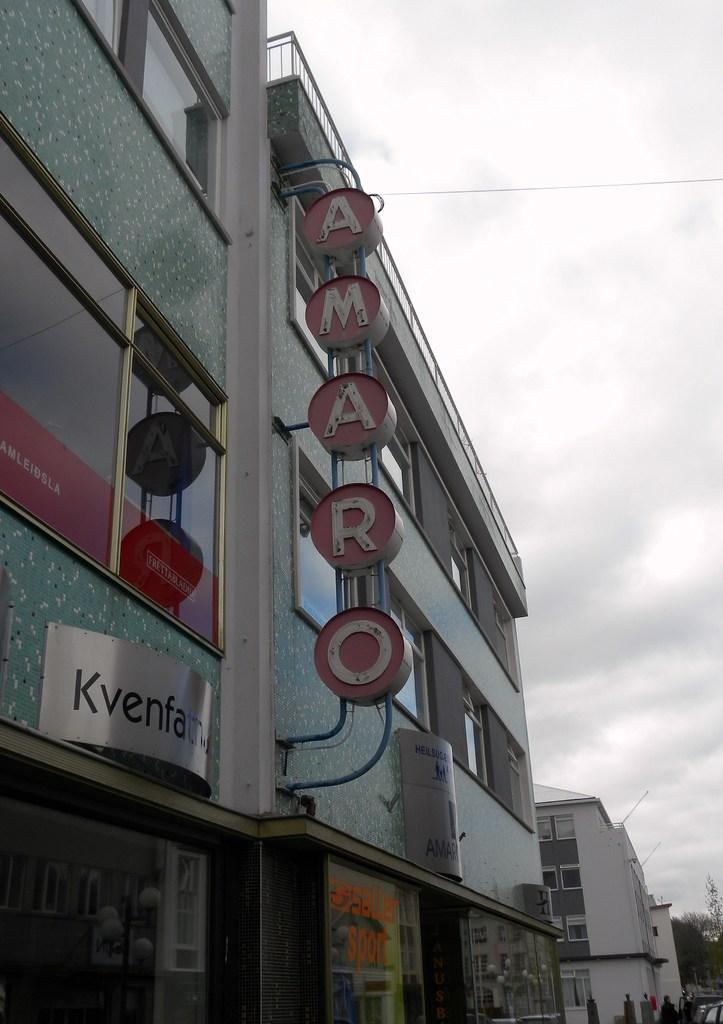What type of structure is present in the image? There is a building in the image. What can be seen on the building in the image? There are name boards on the building in the image. What is happening on the road in the image? There are persons on the road in the image. What type of vegetation is present in the image? There are trees in the image. What is visible in the sky in the image? The sky with clouds is visible in the image. How many cars are parked under the ball and rose in the image? There are no cars, ball, or rose present in the image. 